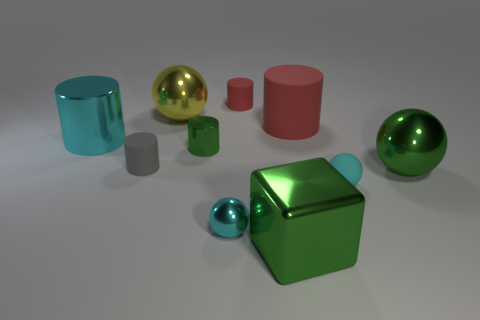What can you say about the lighting in this scene? The lighting in the scene is soft and diffused, coming from the upper left, as indicated by the gentle shadows cast opposite the light source. It creates a calm atmosphere and highlights the reflective surfaces of the glossy objects. 